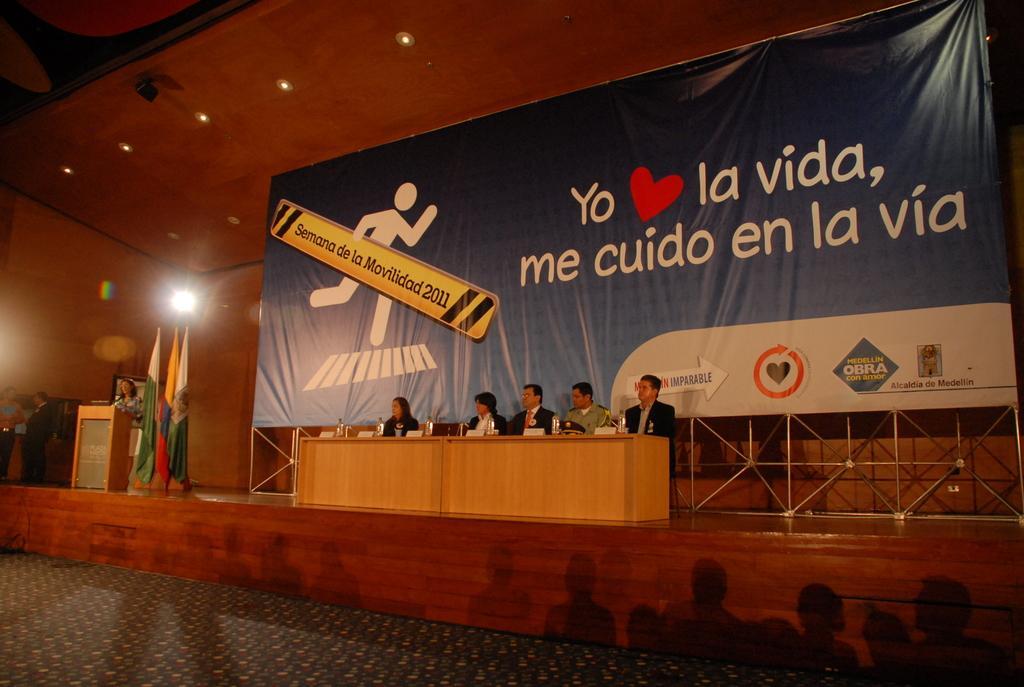Can you describe this image briefly? In the picture we can see a seminar on the stage with a person standing and talking near the desk and beside the person we can see some flags and beside it we can see some people are sitting on the chairs near the desk and they are wearing blazers, ties and shirts and behind them we can see a banner with a advertisement and to the ceiling we can see some lights, and on the floor we can see a floor mat. 